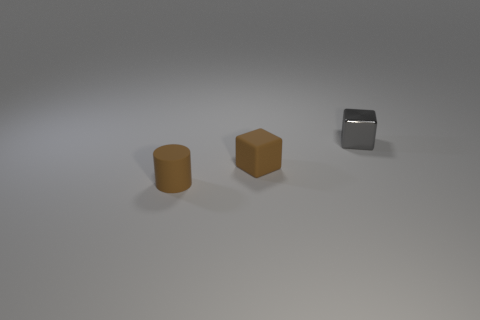Add 2 large blue rubber objects. How many objects exist? 5 Subtract all cylinders. How many objects are left? 2 Add 2 tiny metal cubes. How many tiny metal cubes exist? 3 Subtract 1 brown blocks. How many objects are left? 2 Subtract all small brown objects. Subtract all purple metal cylinders. How many objects are left? 1 Add 2 objects. How many objects are left? 5 